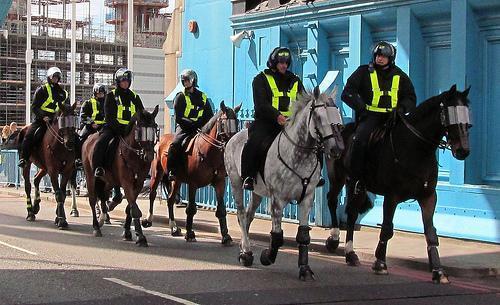How many horses are shown?
Give a very brief answer. 6. 